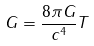Convert formula to latex. <formula><loc_0><loc_0><loc_500><loc_500>G = \frac { 8 \pi G } { c ^ { 4 } } T</formula> 